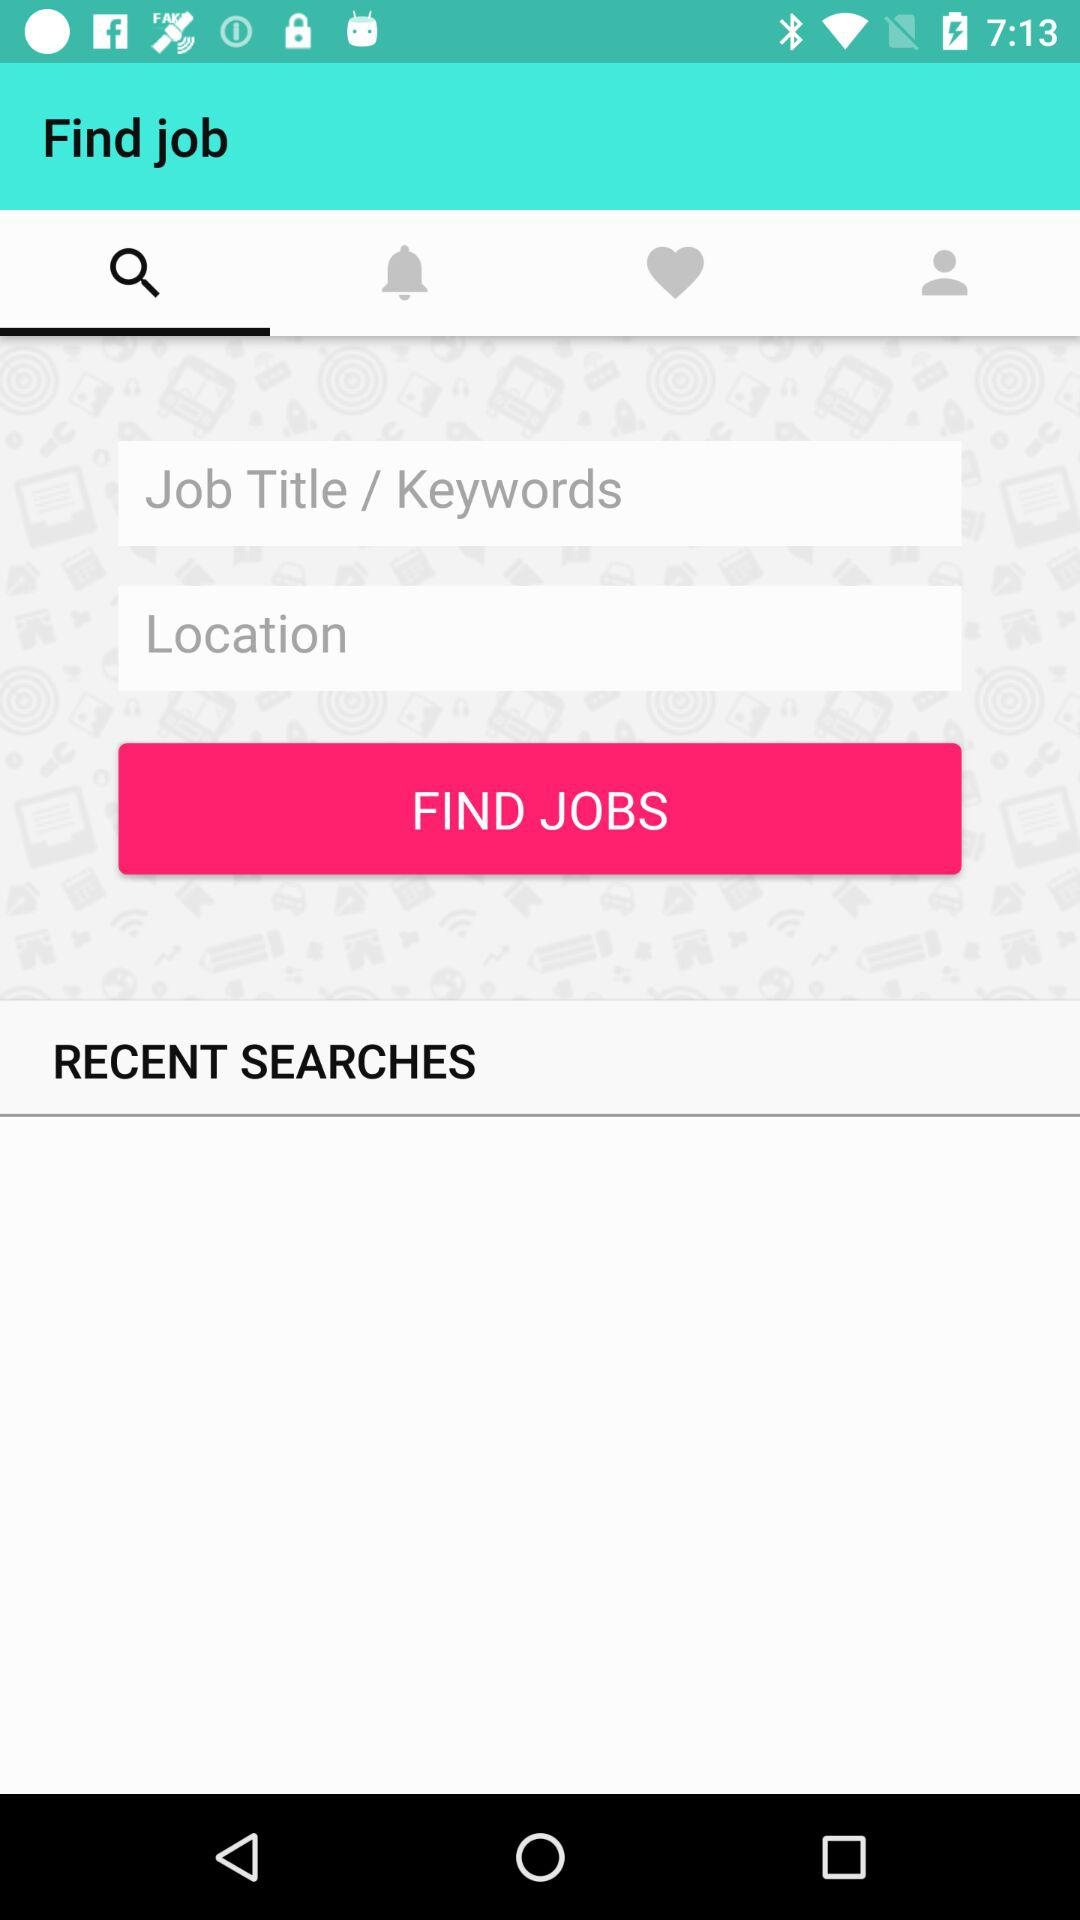Which is the selected tab? The selected tab is "Search". 